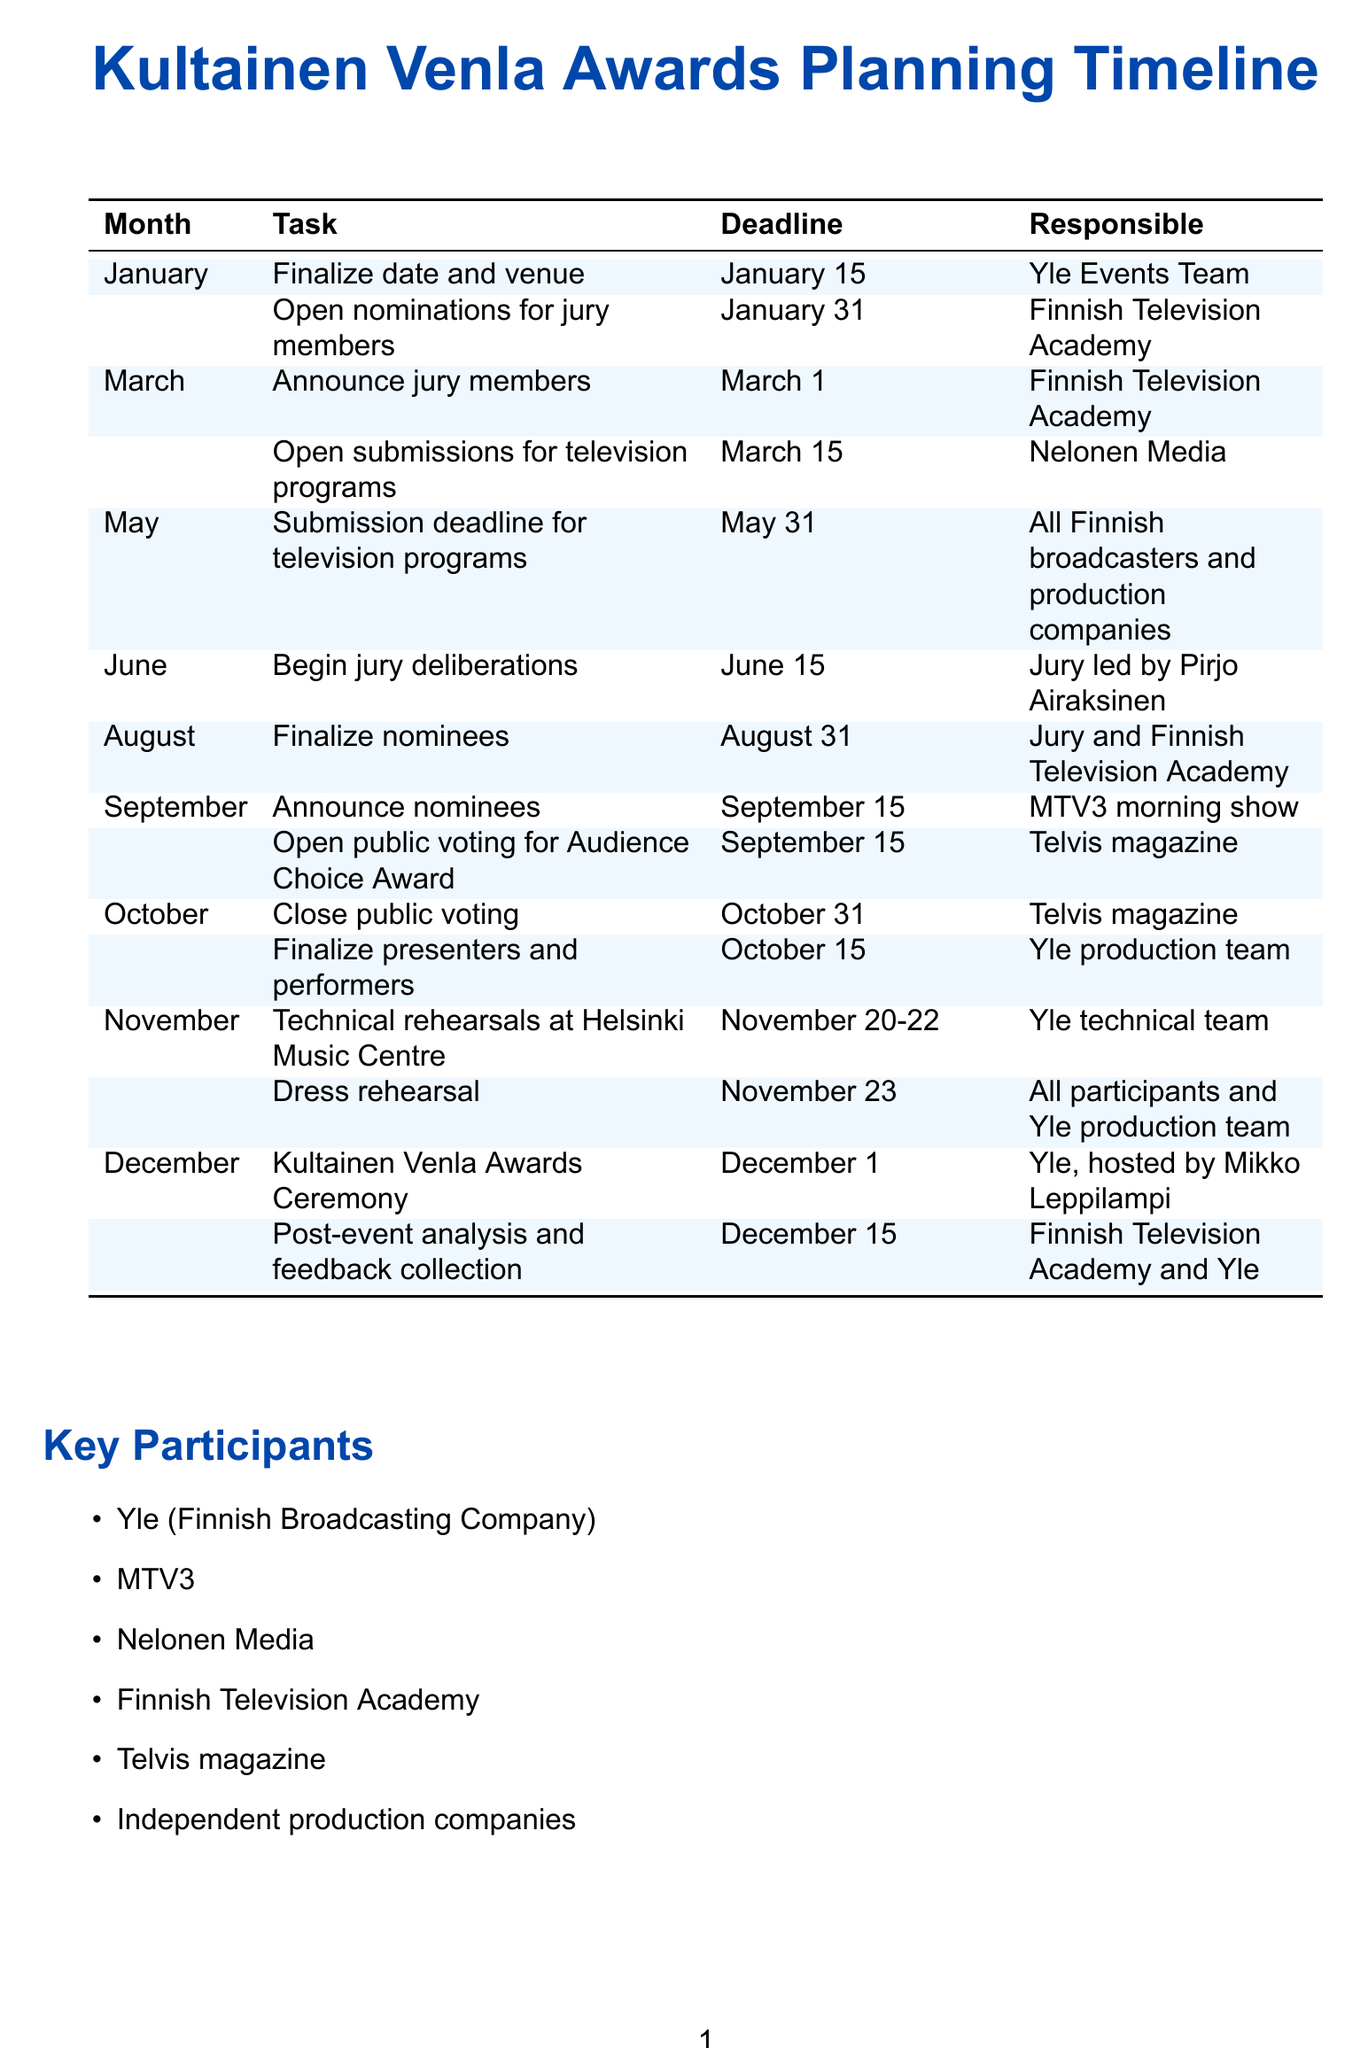What is the date of the awards ceremony? The awards ceremony is scheduled for December 1.
Answer: December 1 Who is responsible for the technical rehearsals? The technical rehearsals are the responsibility of the Yle technical team.
Answer: Yle technical team When does public voting for the Audience Choice Award open? Public voting opens on September 15.
Answer: September 15 What task is to be completed by May 31? The submission deadline for television programs is due by May 31.
Answer: Submission deadline for television programs Who leads the jury deliberations? The jury deliberations are led by Pirjo Airaksinen.
Answer: Pirjo Airaksinen How many days are allocated for technical rehearsals? The technical rehearsals are scheduled for three days from November 20 to November 22.
Answer: November 20-22 Which organization opens nominations for jury members? The nominations for jury members are opened by the Finnish Television Academy.
Answer: Finnish Television Academy What major aspect must be considered during jury selection? There must be representation from both public and commercial broadcasters in the jury.
Answer: Representation from both public and commercial broadcasters What is the deadline for finalizing nominees? The nominees must be finalized by August 31.
Answer: August 31 